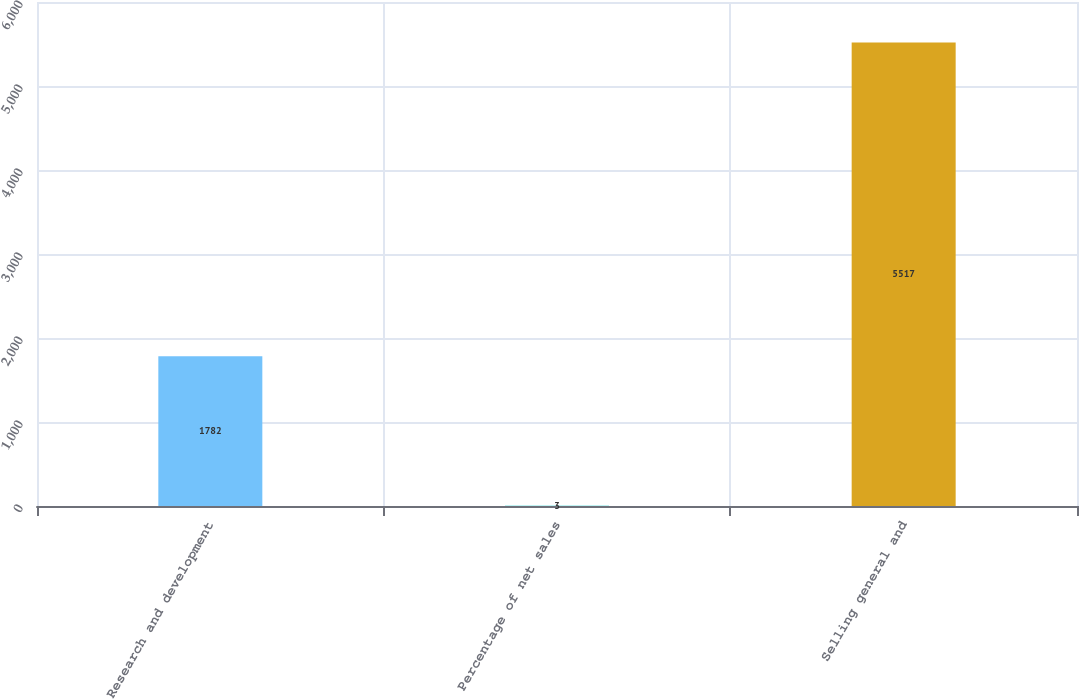Convert chart. <chart><loc_0><loc_0><loc_500><loc_500><bar_chart><fcel>Research and development<fcel>Percentage of net sales<fcel>Selling general and<nl><fcel>1782<fcel>3<fcel>5517<nl></chart> 